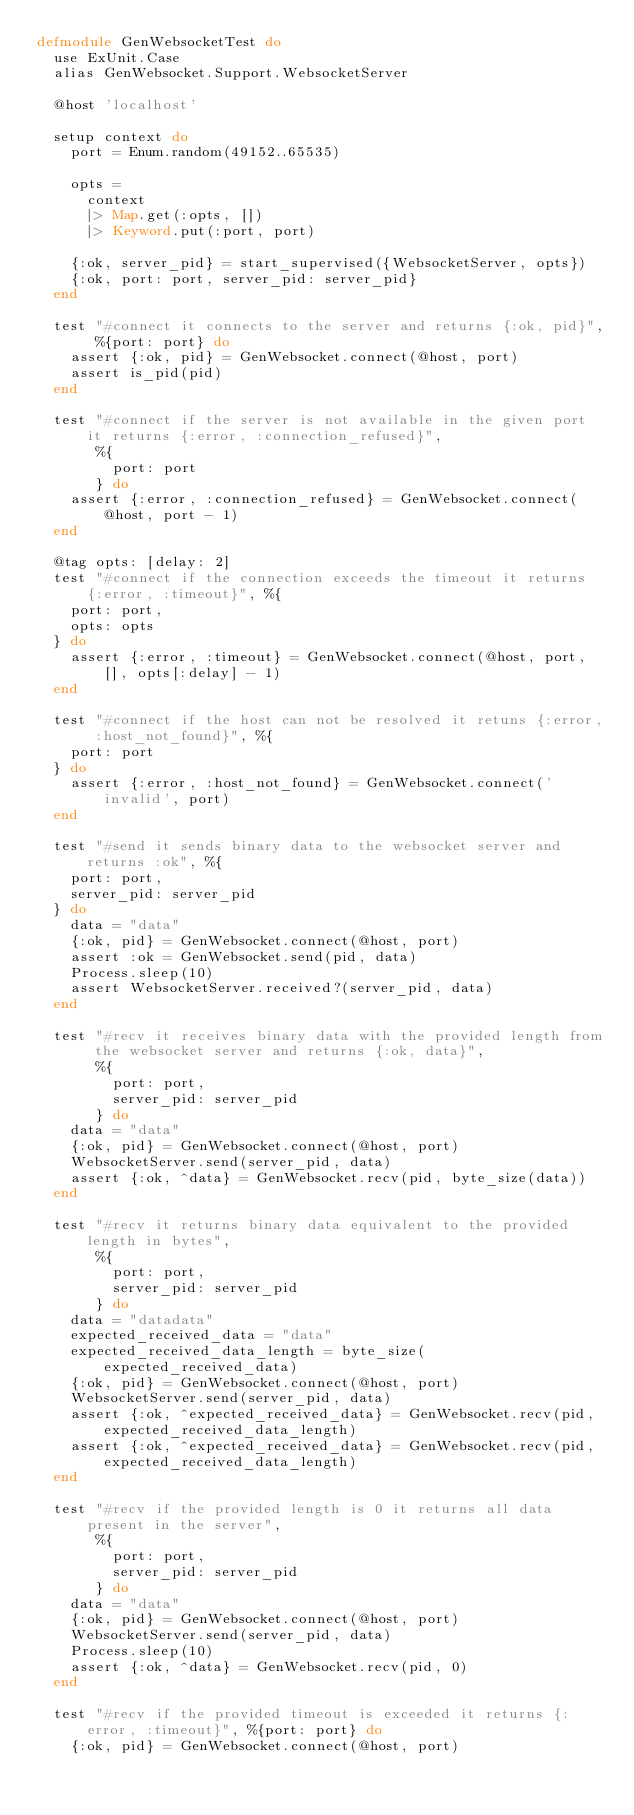<code> <loc_0><loc_0><loc_500><loc_500><_Elixir_>defmodule GenWebsocketTest do
  use ExUnit.Case
  alias GenWebsocket.Support.WebsocketServer

  @host 'localhost'

  setup context do
    port = Enum.random(49152..65535)

    opts =
      context
      |> Map.get(:opts, [])
      |> Keyword.put(:port, port)

    {:ok, server_pid} = start_supervised({WebsocketServer, opts})
    {:ok, port: port, server_pid: server_pid}
  end

  test "#connect it connects to the server and returns {:ok, pid}", %{port: port} do
    assert {:ok, pid} = GenWebsocket.connect(@host, port)
    assert is_pid(pid)
  end

  test "#connect if the server is not available in the given port it returns {:error, :connection_refused}",
       %{
         port: port
       } do
    assert {:error, :connection_refused} = GenWebsocket.connect(@host, port - 1)
  end

  @tag opts: [delay: 2]
  test "#connect if the connection exceeds the timeout it returns {:error, :timeout}", %{
    port: port,
    opts: opts
  } do
    assert {:error, :timeout} = GenWebsocket.connect(@host, port, [], opts[:delay] - 1)
  end

  test "#connect if the host can not be resolved it retuns {:error, :host_not_found}", %{
    port: port
  } do
    assert {:error, :host_not_found} = GenWebsocket.connect('invalid', port)
  end

  test "#send it sends binary data to the websocket server and returns :ok", %{
    port: port,
    server_pid: server_pid
  } do
    data = "data"
    {:ok, pid} = GenWebsocket.connect(@host, port)
    assert :ok = GenWebsocket.send(pid, data)
    Process.sleep(10)
    assert WebsocketServer.received?(server_pid, data)
  end

  test "#recv it receives binary data with the provided length from the websocket server and returns {:ok, data}",
       %{
         port: port,
         server_pid: server_pid
       } do
    data = "data"
    {:ok, pid} = GenWebsocket.connect(@host, port)
    WebsocketServer.send(server_pid, data)
    assert {:ok, ^data} = GenWebsocket.recv(pid, byte_size(data))
  end

  test "#recv it returns binary data equivalent to the provided length in bytes",
       %{
         port: port,
         server_pid: server_pid
       } do
    data = "datadata"
    expected_received_data = "data"
    expected_received_data_length = byte_size(expected_received_data)
    {:ok, pid} = GenWebsocket.connect(@host, port)
    WebsocketServer.send(server_pid, data)
    assert {:ok, ^expected_received_data} = GenWebsocket.recv(pid, expected_received_data_length)
    assert {:ok, ^expected_received_data} = GenWebsocket.recv(pid, expected_received_data_length)
  end

  test "#recv if the provided length is 0 it returns all data present in the server",
       %{
         port: port,
         server_pid: server_pid
       } do
    data = "data"
    {:ok, pid} = GenWebsocket.connect(@host, port)
    WebsocketServer.send(server_pid, data)
    Process.sleep(10)
    assert {:ok, ^data} = GenWebsocket.recv(pid, 0)
  end

  test "#recv if the provided timeout is exceeded it returns {:error, :timeout}", %{port: port} do
    {:ok, pid} = GenWebsocket.connect(@host, port)</code> 